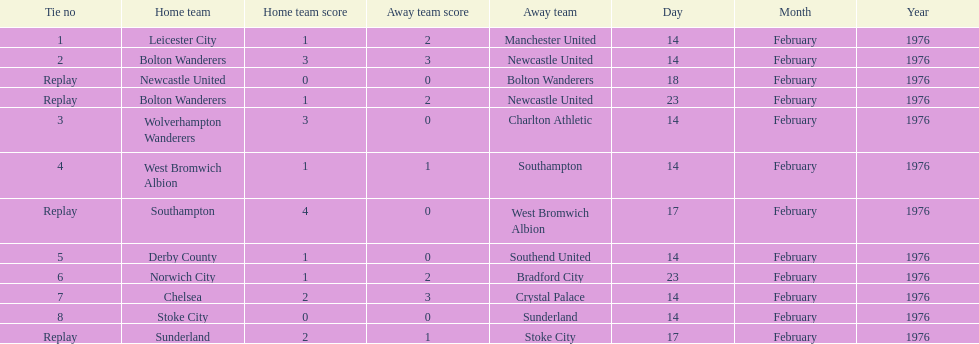Could you parse the entire table? {'header': ['Tie no', 'Home team', 'Home team score', 'Away team score', 'Away team', 'Day', 'Month', 'Year'], 'rows': [['1', 'Leicester City', '1', '2', 'Manchester United', '14', 'February', '1976'], ['2', 'Bolton Wanderers', '3', '3', 'Newcastle United', '14', 'February', '1976'], ['Replay', 'Newcastle United', '0', '0', 'Bolton Wanderers', '18', 'February', '1976'], ['Replay', 'Bolton Wanderers', '1', '2', 'Newcastle United', '23', 'February', '1976'], ['3', 'Wolverhampton Wanderers', '3', '0', 'Charlton Athletic', '14', 'February', '1976'], ['4', 'West Bromwich Albion', '1', '1', 'Southampton', '14', 'February', '1976'], ['Replay', 'Southampton', '4', '0', 'West Bromwich Albion', '17', 'February', '1976'], ['5', 'Derby County', '1', '0', 'Southend United', '14', 'February', '1976'], ['6', 'Norwich City', '1', '2', 'Bradford City', '23', 'February', '1976'], ['7', 'Chelsea', '2', '3', 'Crystal Palace', '14', 'February', '1976'], ['8', 'Stoke City', '0', '0', 'Sunderland', '14', 'February', '1976'], ['Replay', 'Sunderland', '2', '1', 'Stoke City', '17', 'February', '1976']]} How many games played by sunderland are listed here? 2. 